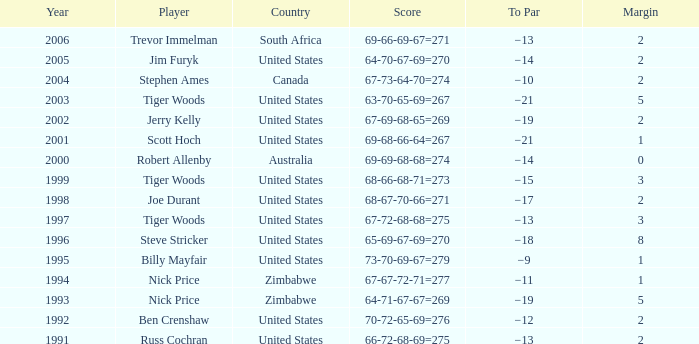Which Margin has a Country of united states, and a Score of 63-70-65-69=267? 5.0. 